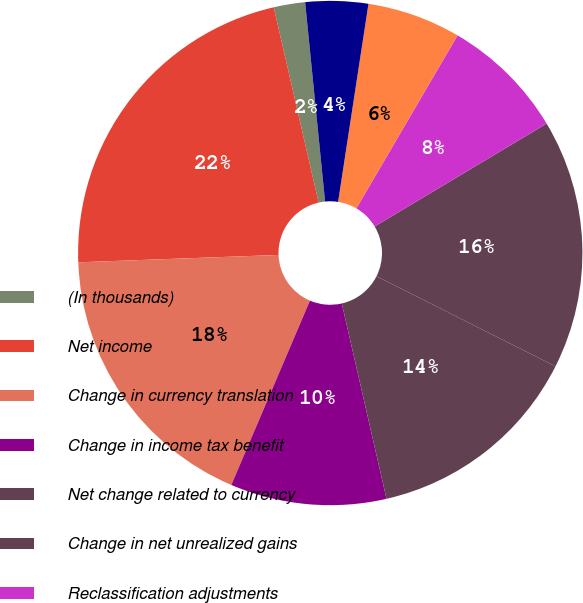Convert chart. <chart><loc_0><loc_0><loc_500><loc_500><pie_chart><fcel>(In thousands)<fcel>Net income<fcel>Change in currency translation<fcel>Change in income tax benefit<fcel>Net change related to currency<fcel>Change in net unrealized gains<fcel>Reclassification adjustments<fcel>Net change related to cash<fcel>Net change related to<nl><fcel>2.01%<fcel>21.99%<fcel>18.0%<fcel>10.0%<fcel>14.0%<fcel>16.0%<fcel>8.0%<fcel>6.0%<fcel>4.01%<nl></chart> 